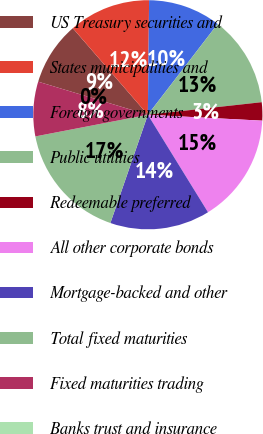Convert chart to OTSL. <chart><loc_0><loc_0><loc_500><loc_500><pie_chart><fcel>US Treasury securities and<fcel>States municipalities and<fcel>Foreign governments<fcel>Public utilities<fcel>Redeemable preferred<fcel>All other corporate bonds<fcel>Mortgage-backed and other<fcel>Total fixed maturities<fcel>Fixed maturities trading<fcel>Banks trust and insurance<nl><fcel>8.97%<fcel>11.54%<fcel>10.26%<fcel>12.82%<fcel>2.57%<fcel>15.38%<fcel>14.1%<fcel>16.67%<fcel>7.69%<fcel>0.0%<nl></chart> 